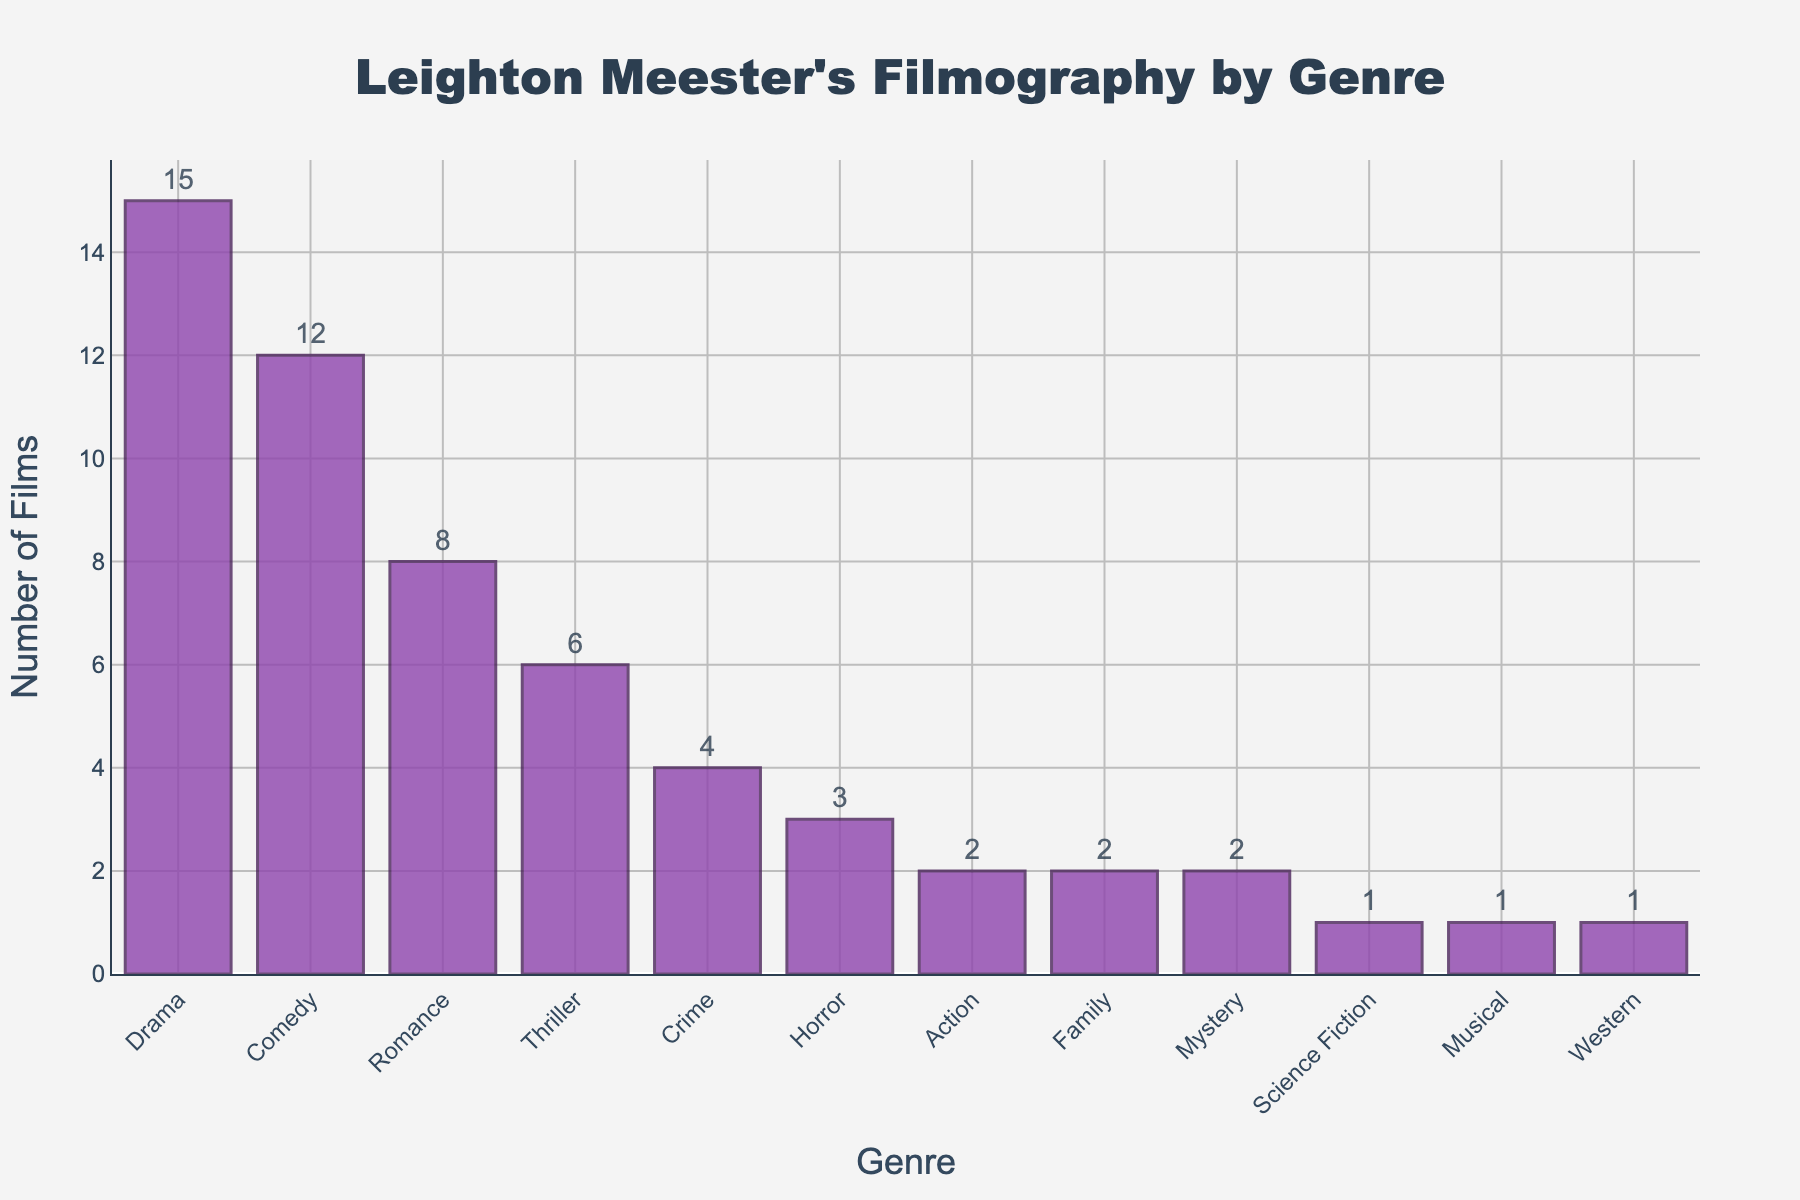Which genre has the highest number of films in Leighton Meester's filmography? The bar with the greatest height in the chart indicates the genre with the highest number of films.
Answer: Drama Which genre has one film in Leighton Meester's filmography? By examining the shortest bars in the chart, we can identify the genres with the smallest counts, where only one bar represents a count of one.
Answer: Science Fiction, Musical, Western How many more Drama films has Leighton Meester done compared to Horror films? Subtract the count of Horror films from the count of Drama films (15 - 3).
Answer: 12 What is the total number of Romance and Comedy films combined? Add the number of Romance films and Comedy films together (8 + 12).
Answer: 20 Which genre has fewer films: Thriller or Crime? Compare the heights of the Thriller and Crime bars.
Answer: Crime How many genres have more than 5 films in Leighton Meester's filmography? Count the bars representing genres with a count greater than 5.
Answer: 3 What is the difference in the number of films between the highest (Drama) and the second-highest (Comedy) genres? Subtract the count of Comedy films from the count of Drama films (15 - 12).
Answer: 3 Is the number of Action and Family films equal? Compare the bars for Action and Family genres, both showing the same height.
Answer: Yes What is the average number of films across all genres Leighton Meester has appeared in? Sum the number of films across all genres and divide by the number of genres. The sum is 55 (15+12+8+6+4+3+2+2+2+1+1+1), and there are 12 genres, so 55/12.
Answer: 4.58 Which genre is represented by a purple colored bar with a count of 8? The purple color fills all bars, so identify the one with a count of 8.
Answer: Romance 